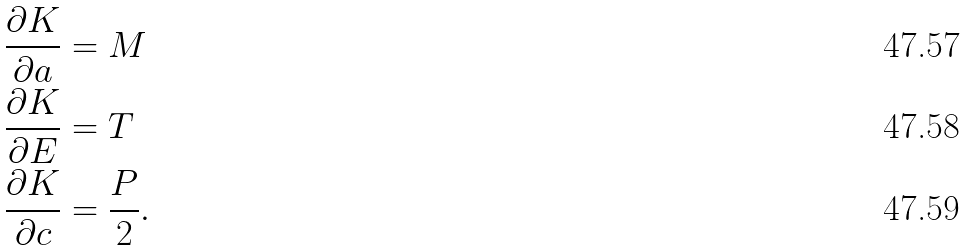<formula> <loc_0><loc_0><loc_500><loc_500>\frac { \partial K } { \partial a } & = M \\ \frac { \partial K } { \partial E } & = T \\ \frac { \partial K } { \partial c } & = \frac { P } { 2 } .</formula> 